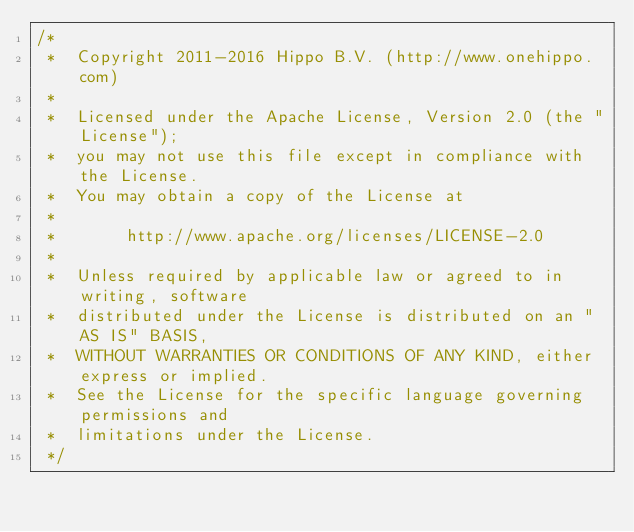<code> <loc_0><loc_0><loc_500><loc_500><_Java_>/*
 *  Copyright 2011-2016 Hippo B.V. (http://www.onehippo.com)
 *
 *  Licensed under the Apache License, Version 2.0 (the "License");
 *  you may not use this file except in compliance with the License.
 *  You may obtain a copy of the License at
 *
 *       http://www.apache.org/licenses/LICENSE-2.0
 *
 *  Unless required by applicable law or agreed to in writing, software
 *  distributed under the License is distributed on an "AS IS" BASIS,
 *  WITHOUT WARRANTIES OR CONDITIONS OF ANY KIND, either express or implied.
 *  See the License for the specific language governing permissions and
 *  limitations under the License.
 */</code> 